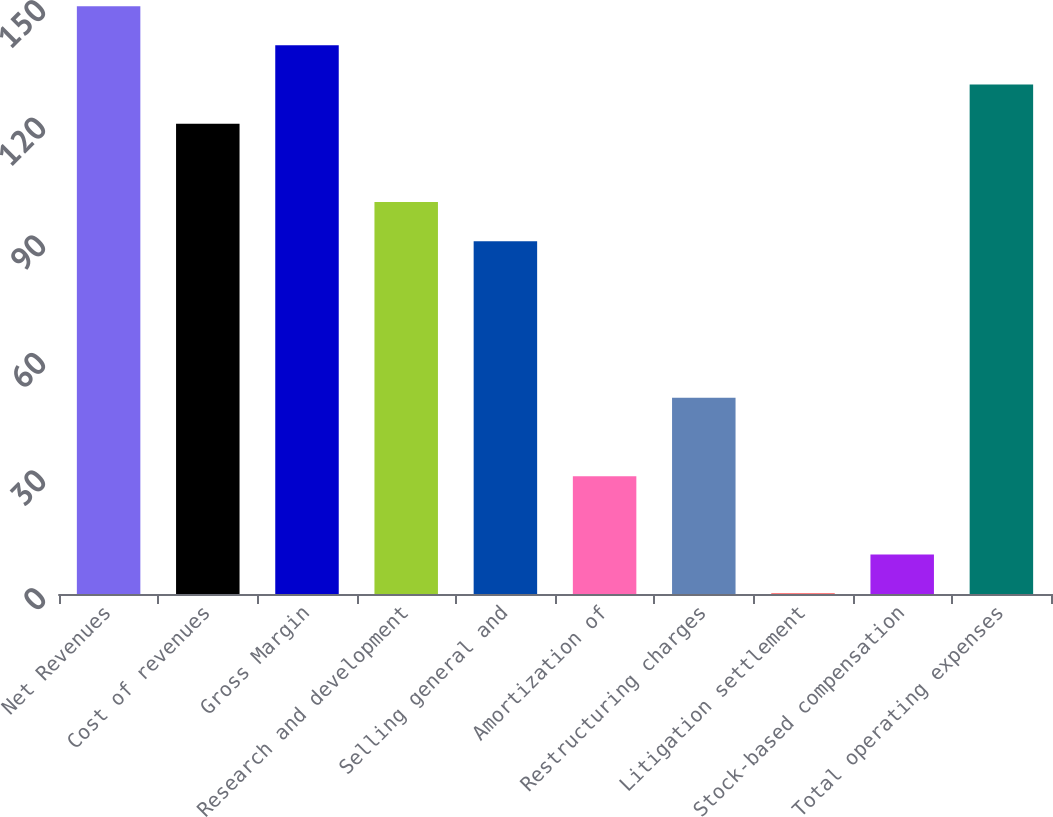<chart> <loc_0><loc_0><loc_500><loc_500><bar_chart><fcel>Net Revenues<fcel>Cost of revenues<fcel>Gross Margin<fcel>Research and development<fcel>Selling general and<fcel>Amortization of<fcel>Restructuring charges<fcel>Litigation settlement<fcel>Stock-based compensation<fcel>Total operating expenses<nl><fcel>149.95<fcel>119.98<fcel>139.96<fcel>100<fcel>90.01<fcel>30.07<fcel>50.05<fcel>0.1<fcel>10.09<fcel>129.97<nl></chart> 